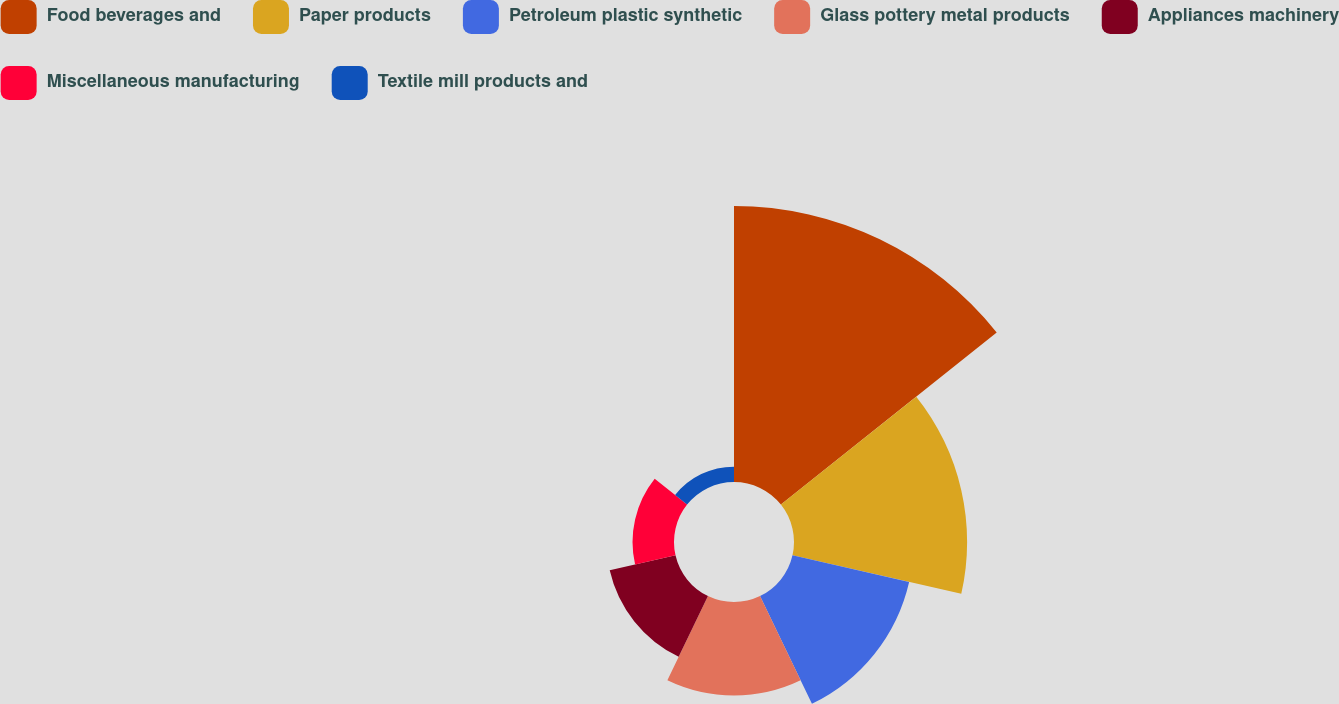Convert chart to OTSL. <chart><loc_0><loc_0><loc_500><loc_500><pie_chart><fcel>Food beverages and<fcel>Paper products<fcel>Petroleum plastic synthetic<fcel>Glass pottery metal products<fcel>Appliances machinery<fcel>Miscellaneous manufacturing<fcel>Textile mill products and<nl><fcel>35.09%<fcel>22.01%<fcel>15.21%<fcel>11.89%<fcel>8.58%<fcel>5.27%<fcel>1.95%<nl></chart> 